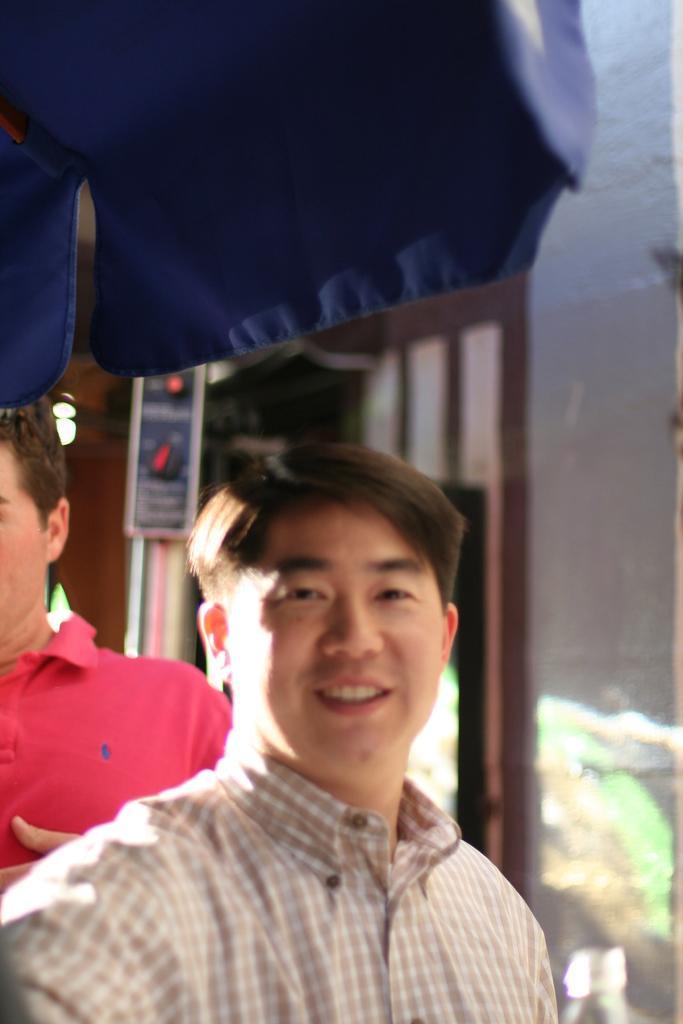Please provide a concise description of this image. In this image we can see two persons. In the background it is looking blur. Also we can see a wall. At the top we can see part of an umbrella at the top. 